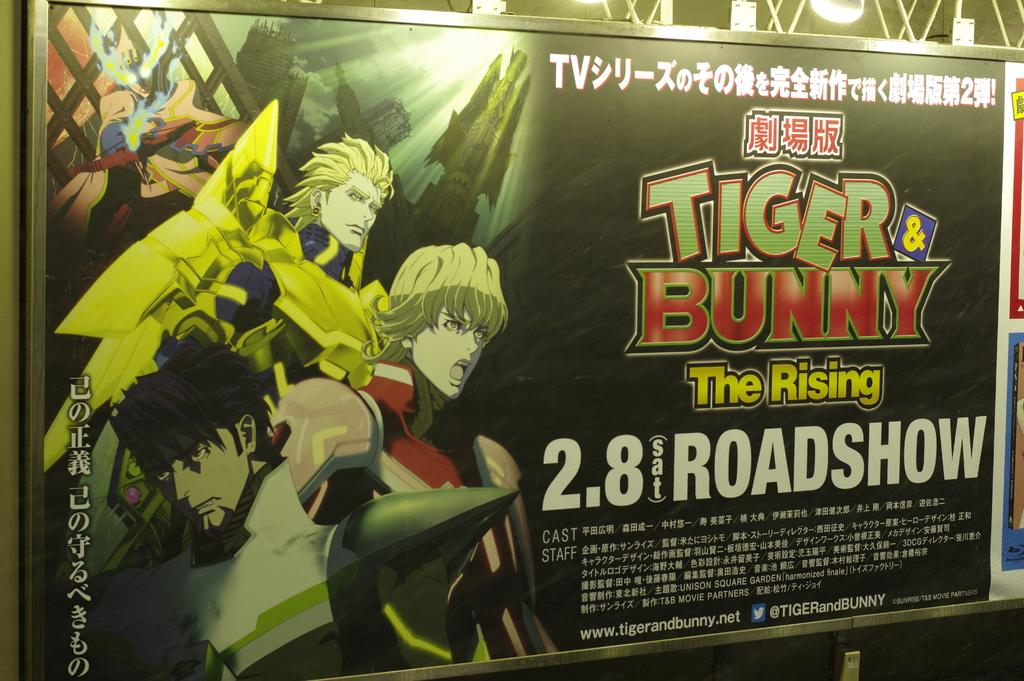<image>
Create a compact narrative representing the image presented. A poster with anime characters on it that says "Tiger & Bunny." 